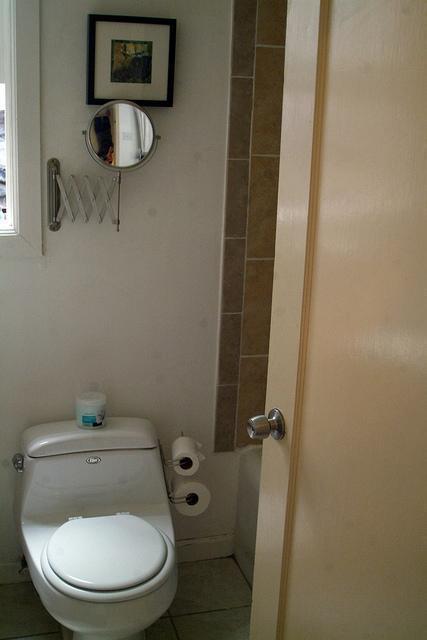How many rolls of toilet paper are there?
Give a very brief answer. 2. How many stacks of bowls are there?
Give a very brief answer. 0. 